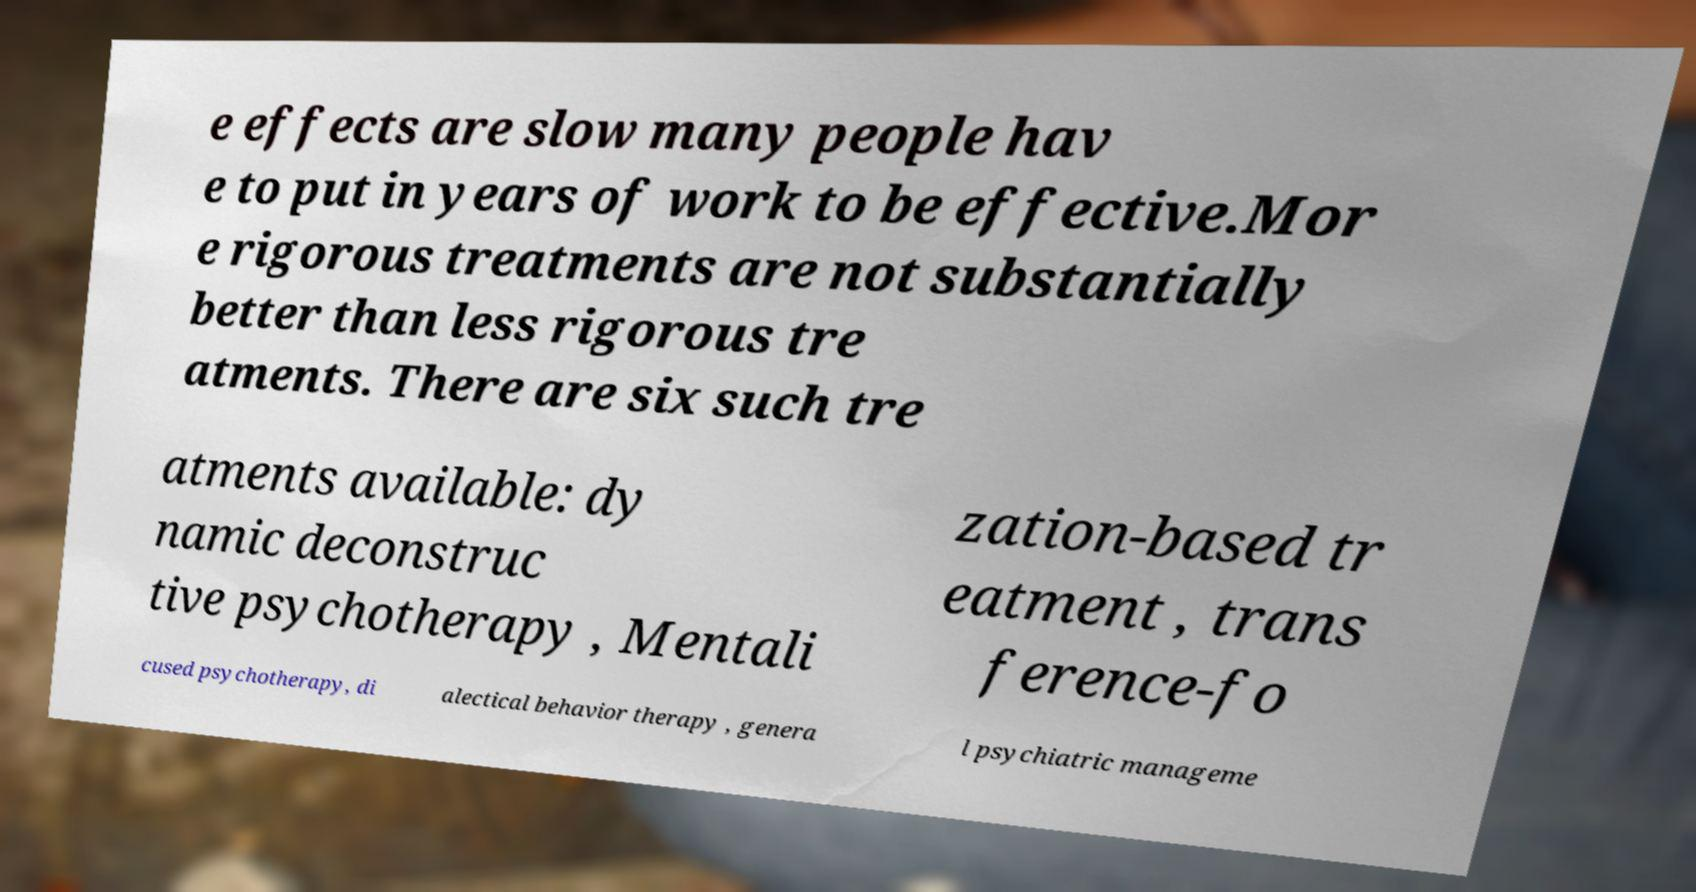What messages or text are displayed in this image? I need them in a readable, typed format. e effects are slow many people hav e to put in years of work to be effective.Mor e rigorous treatments are not substantially better than less rigorous tre atments. There are six such tre atments available: dy namic deconstruc tive psychotherapy , Mentali zation-based tr eatment , trans ference-fo cused psychotherapy, di alectical behavior therapy , genera l psychiatric manageme 